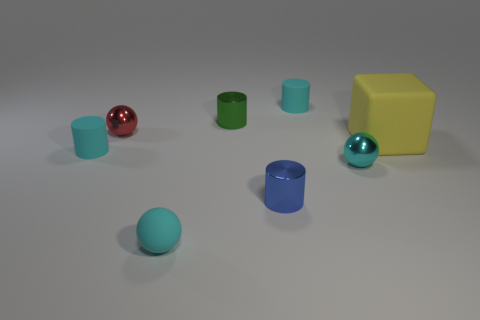Is there any other thing that is the same size as the yellow thing?
Provide a short and direct response. No. Is there a small metal cylinder of the same color as the rubber block?
Give a very brief answer. No. Do the large yellow cube and the small red sphere have the same material?
Your response must be concise. No. What number of things are behind the big yellow cube?
Ensure brevity in your answer.  3. What is the material of the object that is both left of the matte ball and behind the big block?
Your answer should be very brief. Metal. How many metallic things have the same size as the cyan shiny sphere?
Give a very brief answer. 3. There is a matte object in front of the small cyan cylinder that is in front of the yellow object; what is its color?
Your answer should be very brief. Cyan. Are any rubber blocks visible?
Your answer should be compact. Yes. Is the small blue metallic object the same shape as the large yellow matte thing?
Make the answer very short. No. What size is the other ball that is the same color as the matte ball?
Provide a succinct answer. Small. 